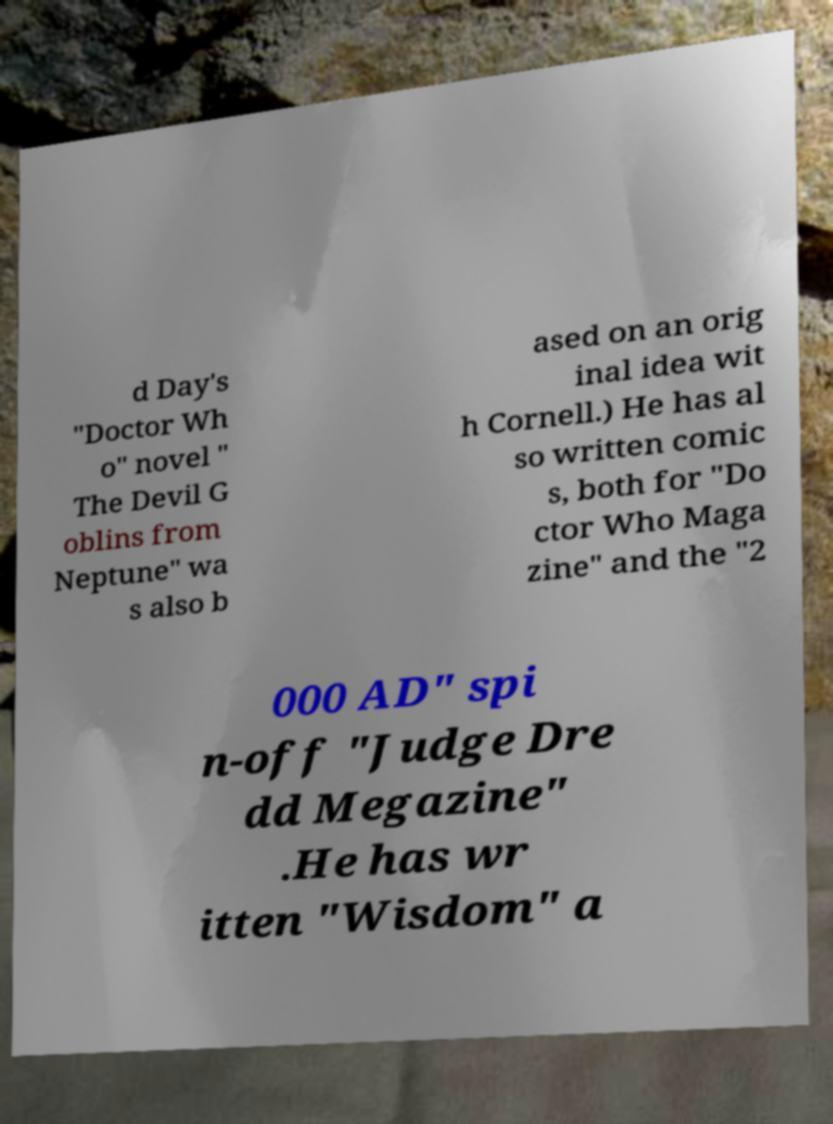Can you read and provide the text displayed in the image?This photo seems to have some interesting text. Can you extract and type it out for me? d Day's "Doctor Wh o" novel " The Devil G oblins from Neptune" wa s also b ased on an orig inal idea wit h Cornell.) He has al so written comic s, both for "Do ctor Who Maga zine" and the "2 000 AD" spi n-off "Judge Dre dd Megazine" .He has wr itten "Wisdom" a 